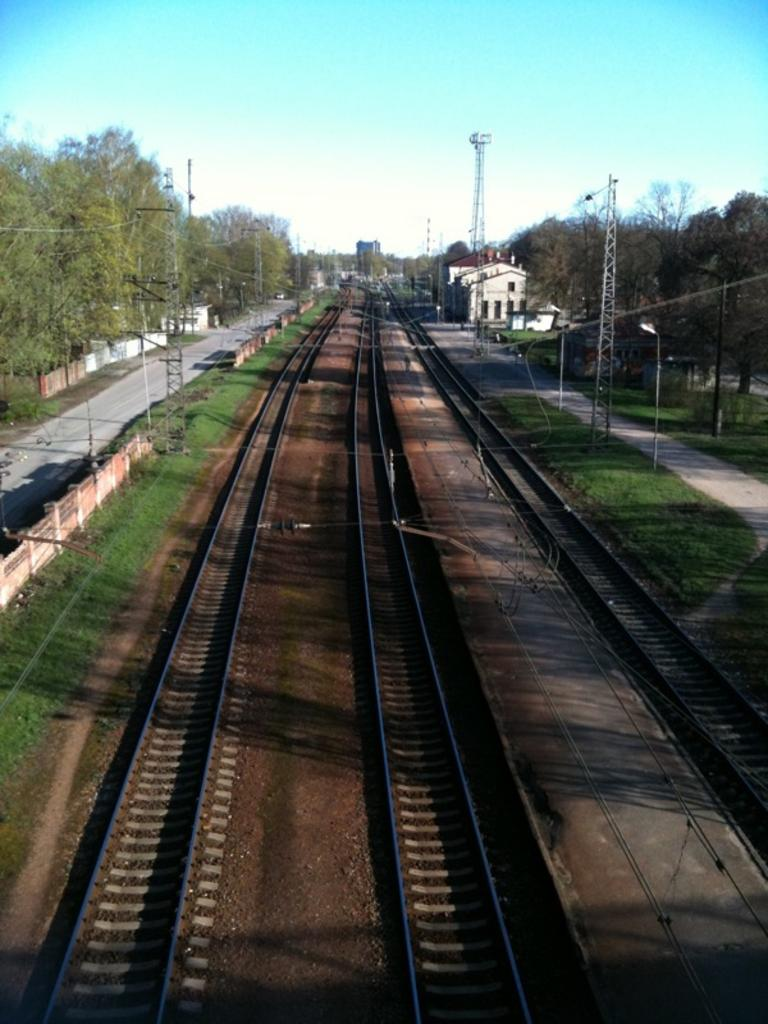What type of vegetation can be seen in the image? There are trees in the image. What type of transportation infrastructure is present in the image? Railway tracks are present in the image. What type of barrier is visible in the image? There is fencing in the image. What type of structures can be seen in the image? Towers are visible in the image. What type of lighting is present in the image? Light poles are present in the image. What is the color of the sky in the image? The sky is a combination of white and blue colors. What is the price of the rifle in the image? There is no rifle present in the image, so it is not possible to determine its price. How does the health of the trees in the image compare to the health of the trees in a different location? The health of the trees in the image cannot be compared to the health of trees in a different location, as there is no information provided about the health of the trees in the image or in any other location. 